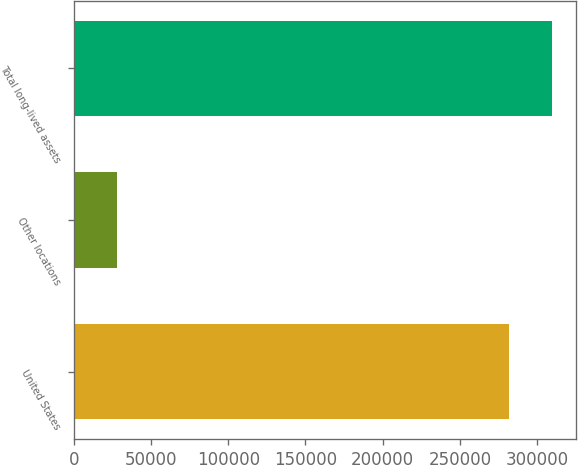<chart> <loc_0><loc_0><loc_500><loc_500><bar_chart><fcel>United States<fcel>Other locations<fcel>Total long-lived assets<nl><fcel>281729<fcel>27991<fcel>309902<nl></chart> 